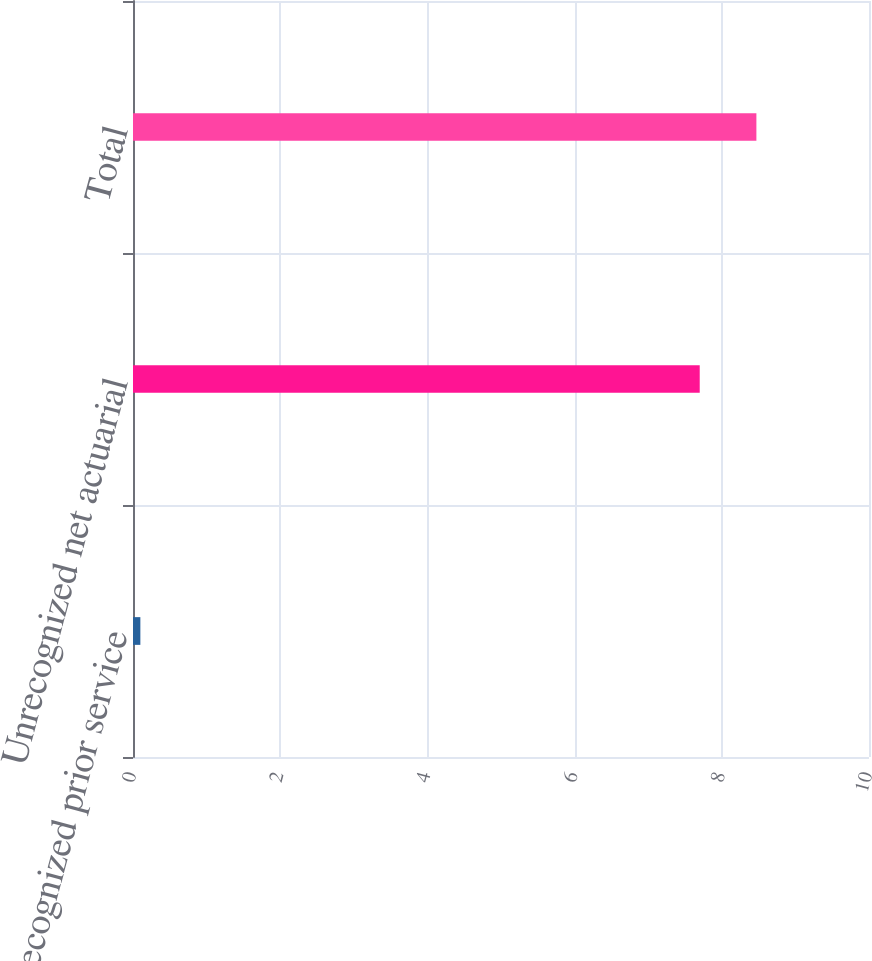Convert chart to OTSL. <chart><loc_0><loc_0><loc_500><loc_500><bar_chart><fcel>Unrecognized prior service<fcel>Unrecognized net actuarial<fcel>Total<nl><fcel>0.1<fcel>7.7<fcel>8.47<nl></chart> 